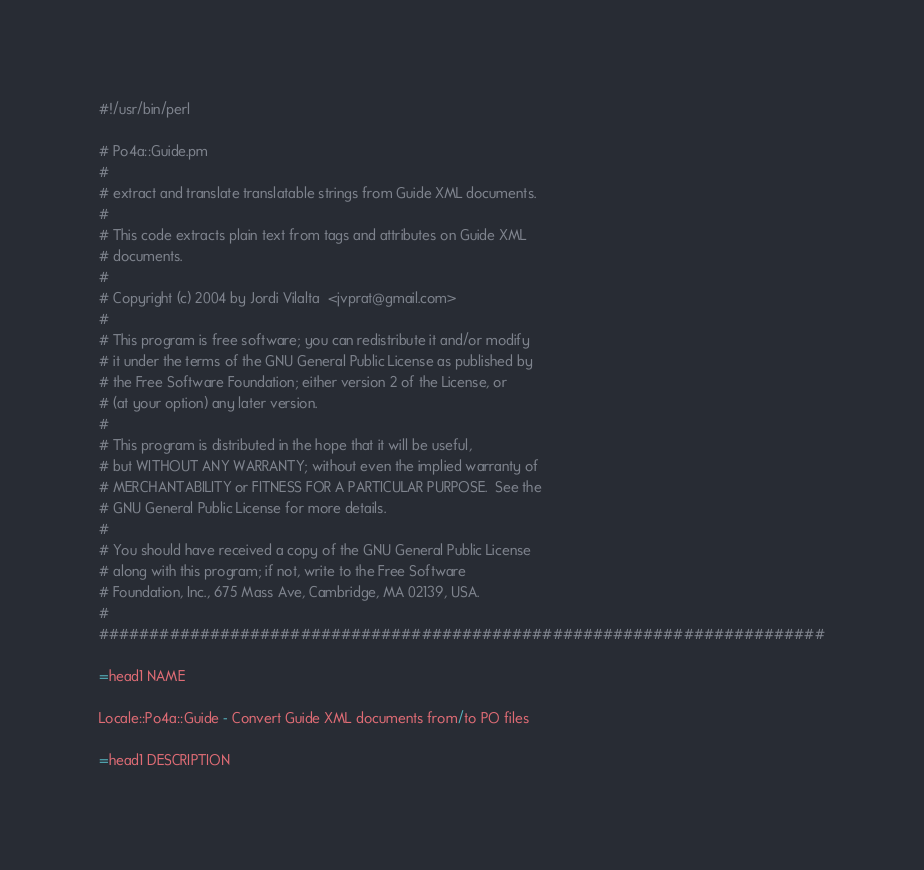Convert code to text. <code><loc_0><loc_0><loc_500><loc_500><_Perl_>#!/usr/bin/perl

# Po4a::Guide.pm 
# 
# extract and translate translatable strings from Guide XML documents.
# 
# This code extracts plain text from tags and attributes on Guide XML
# documents.
#
# Copyright (c) 2004 by Jordi Vilalta  <jvprat@gmail.com>
#
# This program is free software; you can redistribute it and/or modify
# it under the terms of the GNU General Public License as published by
# the Free Software Foundation; either version 2 of the License, or
# (at your option) any later version.
#
# This program is distributed in the hope that it will be useful,
# but WITHOUT ANY WARRANTY; without even the implied warranty of
# MERCHANTABILITY or FITNESS FOR A PARTICULAR PURPOSE.  See the
# GNU General Public License for more details.
#
# You should have received a copy of the GNU General Public License
# along with this program; if not, write to the Free Software
# Foundation, Inc., 675 Mass Ave, Cambridge, MA 02139, USA.
#
########################################################################

=head1 NAME

Locale::Po4a::Guide - Convert Guide XML documents from/to PO files

=head1 DESCRIPTION
</code> 